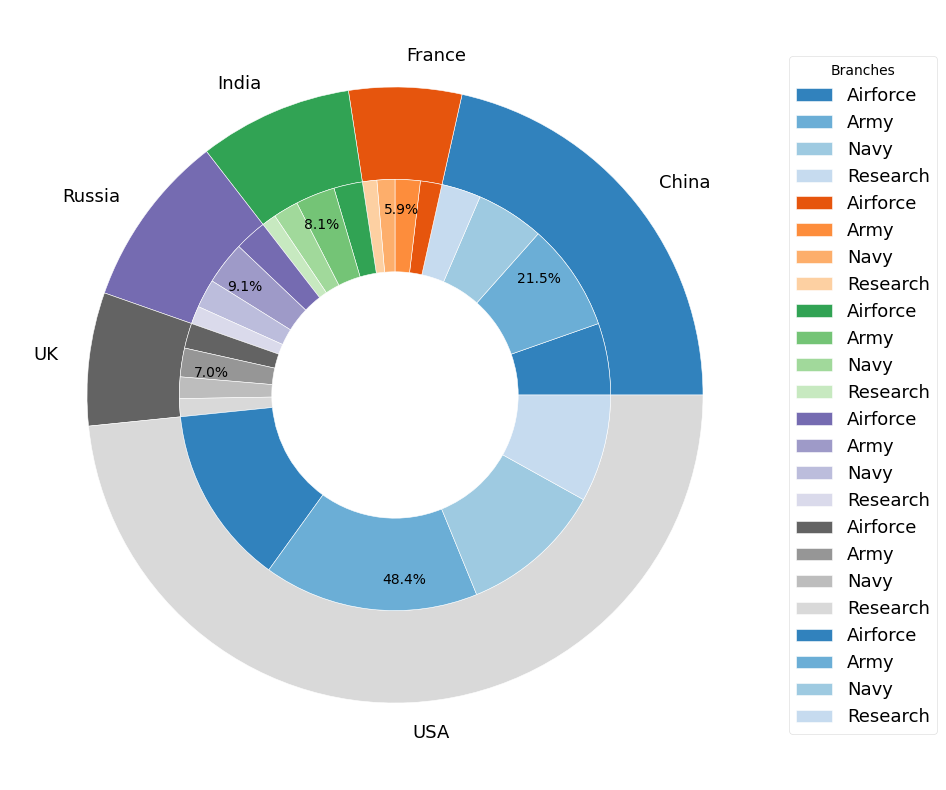What percentage of total military spending is attributed to the USA? The outer pie chart shows that the USA's segment is labeled with its percentage. This value can be directly read off the chart.
Answer: USA segment is labeled as 45.5% What is the combined spending on the Airforce by China and Russia? Identify the expenditure for Airforce for both China and Russia from the inner pie chart segments, then add them together: 100 billion USD (China) + 45 billion USD (Russia) = 145 billion USD
Answer: 145 billion USD Which country spends more on the Navy, the UK or France? Locate the segments corresponding to Navy spending for both the UK and France on the inner pie chart. Compare the size of these segments.
Answer: UK Among the listed countries, which branches collectively receive the least funding in total? Sum up the spending for each branch across all countries and compare the total amounts: Army Sum (300+150+60+55+40+35), Navy Sum (200+95+40+35+30+25), Airforce Sum (250+100+45+40+35+30), Research Sum (150+55+25+20+25+20). Find the branch with the lowest total.
Answer: Research What percentage of India's military budget is spent on Research? Identify the segment that represents India's Research spending in the inner pie chart and read its percentage label.
Answer: India's pie segment for Research is 12.5% What is the difference between the USA's spending on the Army and China's total military spending? From the inner segments, the USA's Army spending is 300 billion USD. China's outer segment indicates total spending of 400 billion USD. Subtract China's total from the USA's Army spending: 300 billion USD - 400 billion USD = -100 billion USD
Answer: -100 billion USD Which country has the most varied distribution of spending among its military branches? Observe the inner pie segments for each country. Look for the country where the segments vary the most in size compared to each other.
Answer: USA What is the total spending on military branches excluding the Army and Navy across all countries? Sum up the spending on the Airforce and Research for all listed countries: (250+100+45+40+35+30) + (150+55+25+20+25+20) = 830 billion USD
Answer: 830 billion USD 